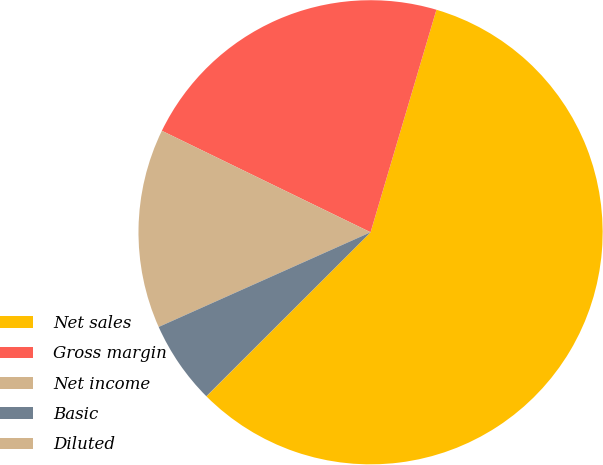Convert chart to OTSL. <chart><loc_0><loc_0><loc_500><loc_500><pie_chart><fcel>Net sales<fcel>Gross margin<fcel>Net income<fcel>Basic<fcel>Diluted<nl><fcel>57.91%<fcel>22.37%<fcel>13.89%<fcel>5.8%<fcel>0.01%<nl></chart> 